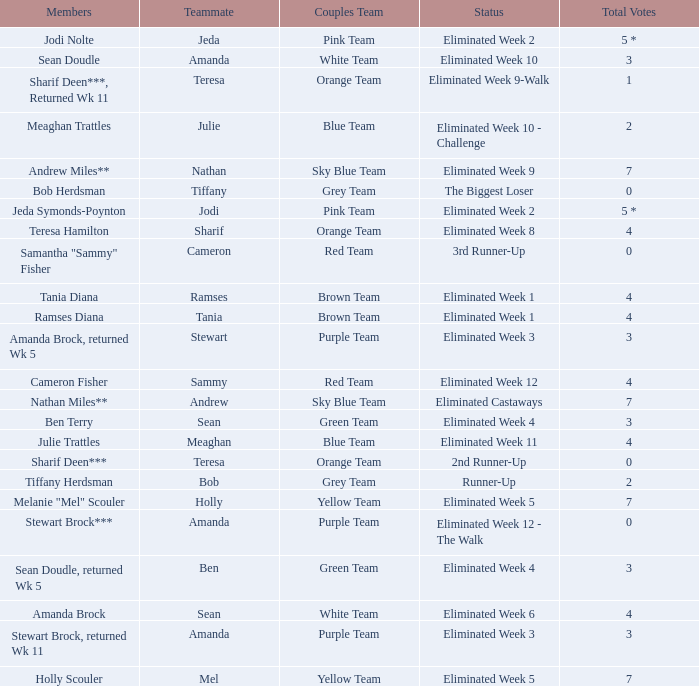Who got 0 complete votes in the purple team? Eliminated Week 12 - The Walk. Parse the table in full. {'header': ['Members', 'Teammate', 'Couples Team', 'Status', 'Total Votes'], 'rows': [['Jodi Nolte', 'Jeda', 'Pink Team', 'Eliminated Week 2', '5 *'], ['Sean Doudle', 'Amanda', 'White Team', 'Eliminated Week 10', '3'], ['Sharif Deen***, Returned Wk 11', 'Teresa', 'Orange Team', 'Eliminated Week 9-Walk', '1'], ['Meaghan Trattles', 'Julie', 'Blue Team', 'Eliminated Week 10 - Challenge', '2'], ['Andrew Miles**', 'Nathan', 'Sky Blue Team', 'Eliminated Week 9', '7'], ['Bob Herdsman', 'Tiffany', 'Grey Team', 'The Biggest Loser', '0'], ['Jeda Symonds-Poynton', 'Jodi', 'Pink Team', 'Eliminated Week 2', '5 *'], ['Teresa Hamilton', 'Sharif', 'Orange Team', 'Eliminated Week 8', '4'], ['Samantha "Sammy" Fisher', 'Cameron', 'Red Team', '3rd Runner-Up', '0'], ['Tania Diana', 'Ramses', 'Brown Team', 'Eliminated Week 1', '4'], ['Ramses Diana', 'Tania', 'Brown Team', 'Eliminated Week 1', '4'], ['Amanda Brock, returned Wk 5', 'Stewart', 'Purple Team', 'Eliminated Week 3', '3'], ['Cameron Fisher', 'Sammy', 'Red Team', 'Eliminated Week 12', '4'], ['Nathan Miles**', 'Andrew', 'Sky Blue Team', 'Eliminated Castaways', '7'], ['Ben Terry', 'Sean', 'Green Team', 'Eliminated Week 4', '3'], ['Julie Trattles', 'Meaghan', 'Blue Team', 'Eliminated Week 11', '4'], ['Sharif Deen***', 'Teresa', 'Orange Team', '2nd Runner-Up', '0'], ['Tiffany Herdsman', 'Bob', 'Grey Team', 'Runner-Up', '2'], ['Melanie "Mel" Scouler', 'Holly', 'Yellow Team', 'Eliminated Week 5', '7'], ['Stewart Brock***', 'Amanda', 'Purple Team', 'Eliminated Week 12 - The Walk', '0'], ['Sean Doudle, returned Wk 5', 'Ben', 'Green Team', 'Eliminated Week 4', '3'], ['Amanda Brock', 'Sean', 'White Team', 'Eliminated Week 6', '4'], ['Stewart Brock, returned Wk 11', 'Amanda', 'Purple Team', 'Eliminated Week 3', '3'], ['Holly Scouler', 'Mel', 'Yellow Team', 'Eliminated Week 5', '7']]} 